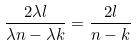Convert formula to latex. <formula><loc_0><loc_0><loc_500><loc_500>\frac { 2 \lambda l } { \lambda n - \lambda k } = \frac { 2 l } { n - k }</formula> 